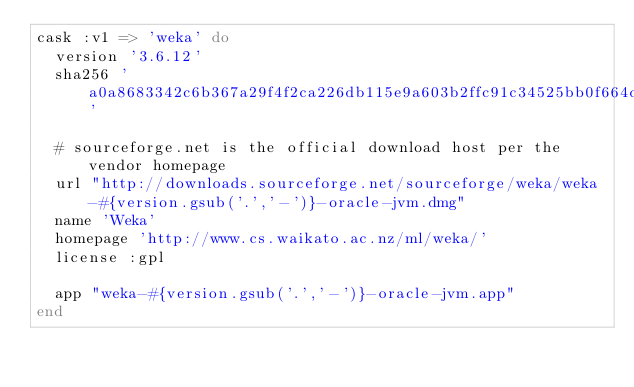Convert code to text. <code><loc_0><loc_0><loc_500><loc_500><_Ruby_>cask :v1 => 'weka' do
  version '3.6.12'
  sha256 'a0a8683342c6b367a29f4f2ca226db115e9a603b2ffc91c34525bb0f664d7b8c'

  # sourceforge.net is the official download host per the vendor homepage
  url "http://downloads.sourceforge.net/sourceforge/weka/weka-#{version.gsub('.','-')}-oracle-jvm.dmg"
  name 'Weka'
  homepage 'http://www.cs.waikato.ac.nz/ml/weka/'
  license :gpl

  app "weka-#{version.gsub('.','-')}-oracle-jvm.app"
end
</code> 